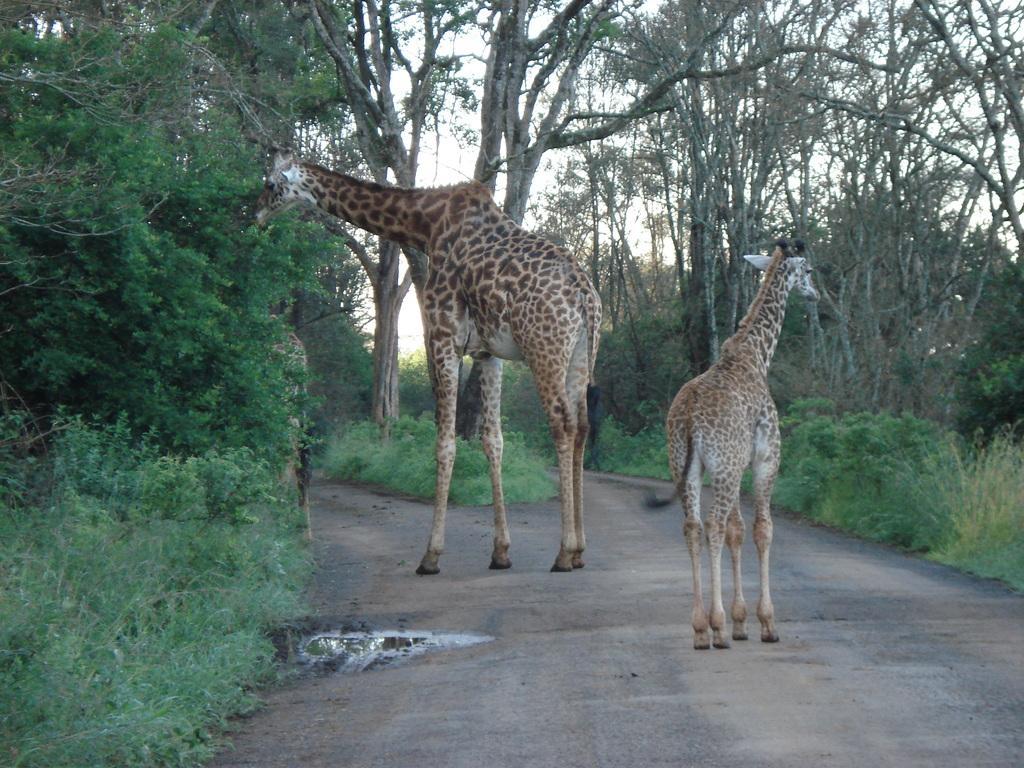How would you summarize this image in a sentence or two? In this image we can see few giraffes on the road and there are some plants and trees and we can see the sky. 